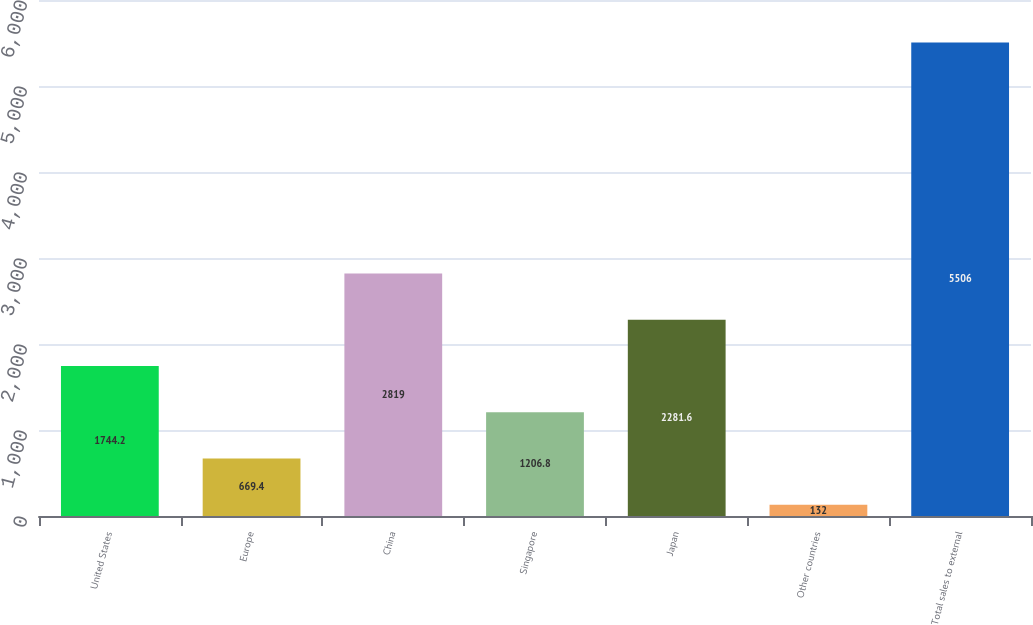Convert chart. <chart><loc_0><loc_0><loc_500><loc_500><bar_chart><fcel>United States<fcel>Europe<fcel>China<fcel>Singapore<fcel>Japan<fcel>Other countries<fcel>Total sales to external<nl><fcel>1744.2<fcel>669.4<fcel>2819<fcel>1206.8<fcel>2281.6<fcel>132<fcel>5506<nl></chart> 